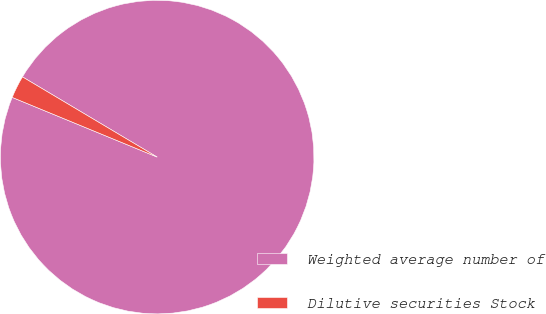Convert chart to OTSL. <chart><loc_0><loc_0><loc_500><loc_500><pie_chart><fcel>Weighted average number of<fcel>Dilutive securities Stock<nl><fcel>97.67%<fcel>2.33%<nl></chart> 